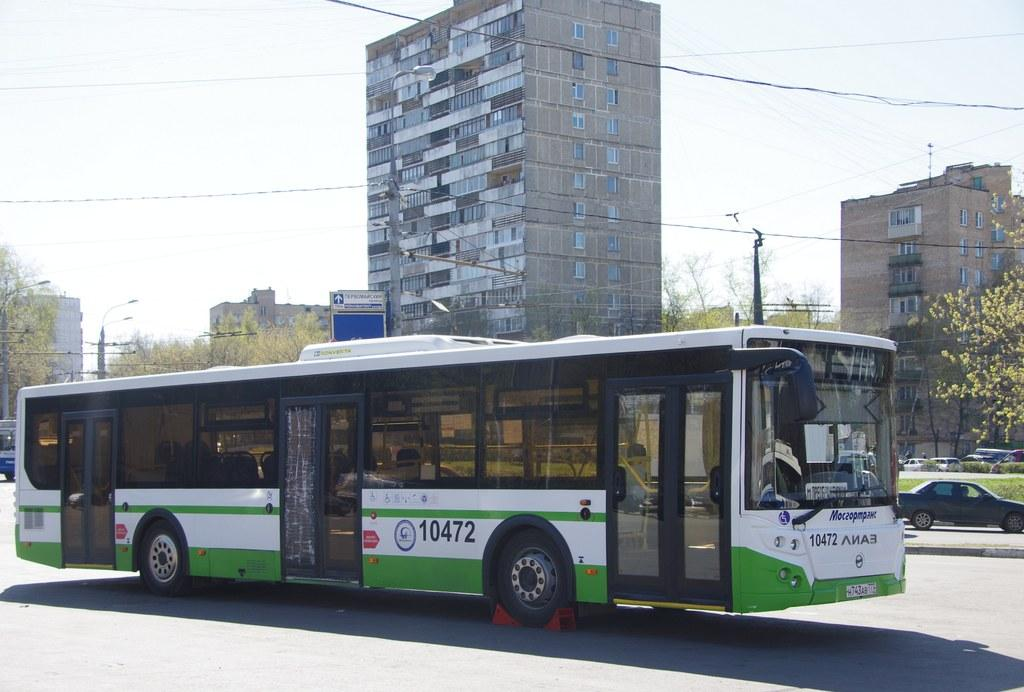<image>
Relay a brief, clear account of the picture shown. Bus number 10472 is white with green stripes on the bottom half. 